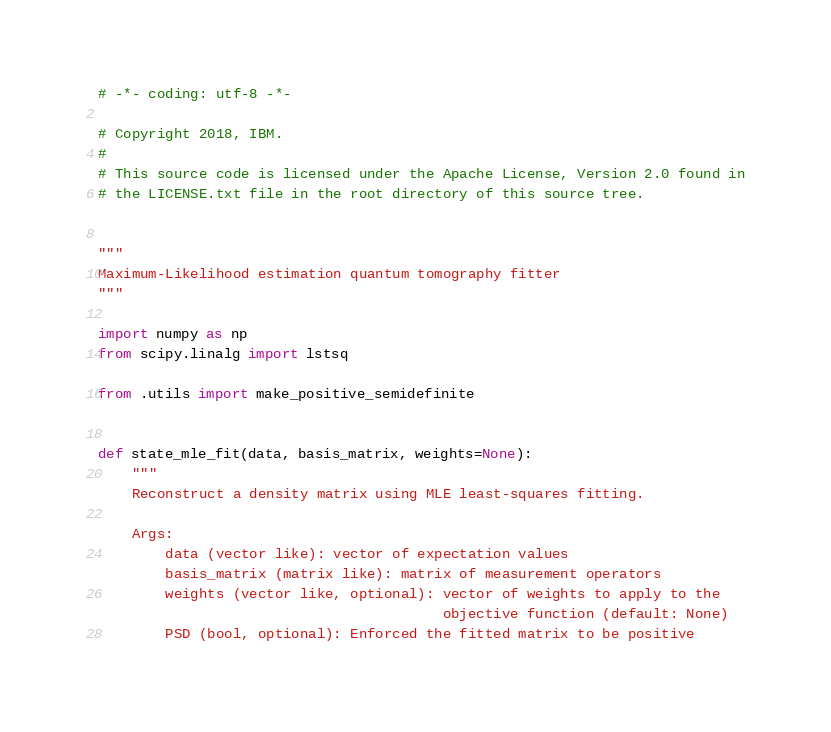Convert code to text. <code><loc_0><loc_0><loc_500><loc_500><_Python_># -*- coding: utf-8 -*-

# Copyright 2018, IBM.
#
# This source code is licensed under the Apache License, Version 2.0 found in
# the LICENSE.txt file in the root directory of this source tree.


"""
Maximum-Likelihood estimation quantum tomography fitter
"""

import numpy as np
from scipy.linalg import lstsq

from .utils import make_positive_semidefinite


def state_mle_fit(data, basis_matrix, weights=None):
    """
    Reconstruct a density matrix using MLE least-squares fitting.

    Args:
        data (vector like): vector of expectation values
        basis_matrix (matrix like): matrix of measurement operators
        weights (vector like, optional): vector of weights to apply to the
                                         objective function (default: None)
        PSD (bool, optional): Enforced the fitted matrix to be positive</code> 